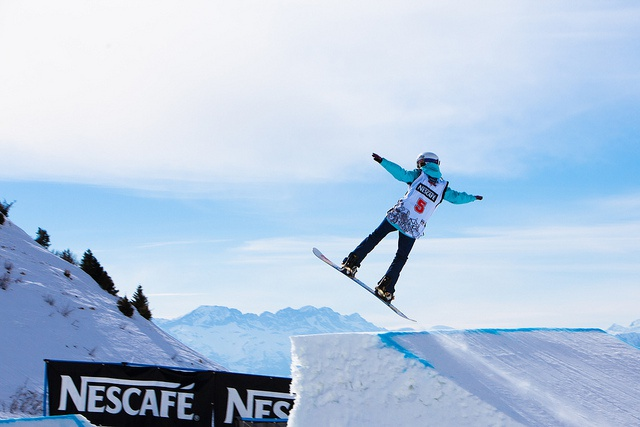Describe the objects in this image and their specific colors. I can see people in white, black, lightblue, and teal tones and snowboard in white, lightgray, black, and darkgray tones in this image. 